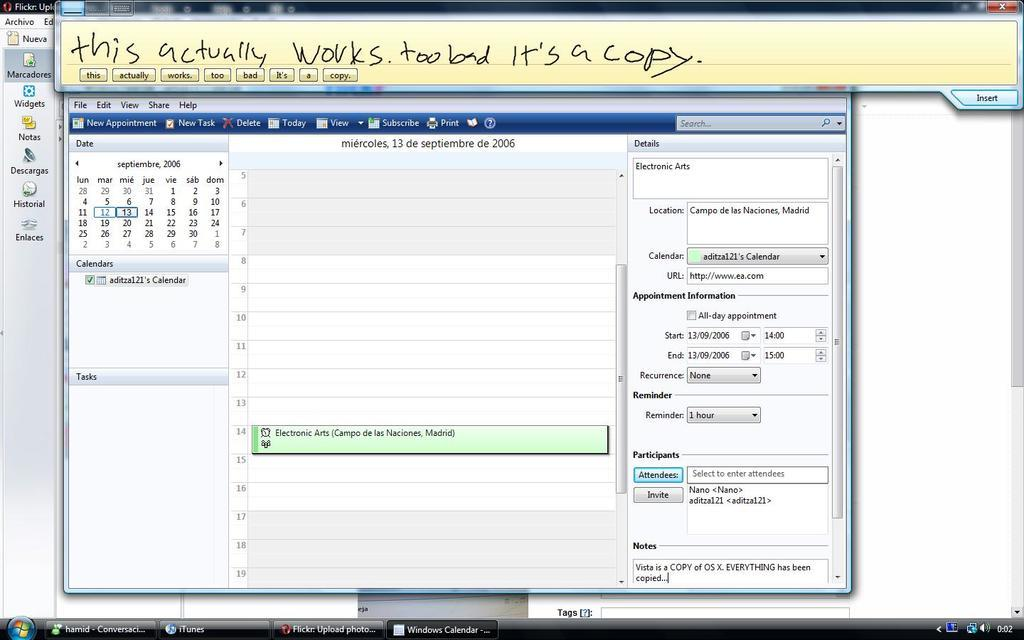<image>
Render a clear and concise summary of the photo. The writing at the top of the calendar page says that this actually works. 